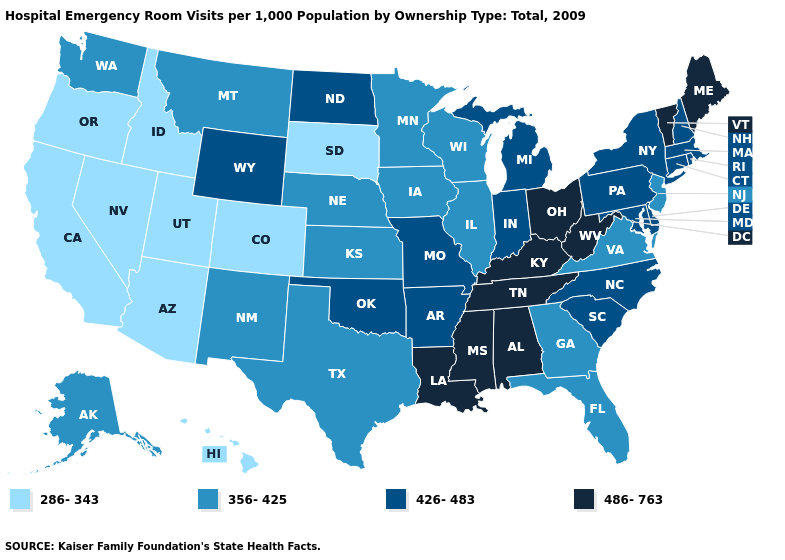Name the states that have a value in the range 426-483?
Short answer required. Arkansas, Connecticut, Delaware, Indiana, Maryland, Massachusetts, Michigan, Missouri, New Hampshire, New York, North Carolina, North Dakota, Oklahoma, Pennsylvania, Rhode Island, South Carolina, Wyoming. What is the value of Montana?
Write a very short answer. 356-425. Does California have a higher value than Michigan?
Answer briefly. No. Does the map have missing data?
Short answer required. No. What is the value of North Carolina?
Be succinct. 426-483. Name the states that have a value in the range 286-343?
Short answer required. Arizona, California, Colorado, Hawaii, Idaho, Nevada, Oregon, South Dakota, Utah. What is the value of Maine?
Quick response, please. 486-763. Does Alabama have the same value as Mississippi?
Give a very brief answer. Yes. What is the value of Arizona?
Quick response, please. 286-343. Name the states that have a value in the range 286-343?
Be succinct. Arizona, California, Colorado, Hawaii, Idaho, Nevada, Oregon, South Dakota, Utah. Which states hav the highest value in the South?
Concise answer only. Alabama, Kentucky, Louisiana, Mississippi, Tennessee, West Virginia. Does Oregon have the lowest value in the West?
Short answer required. Yes. Name the states that have a value in the range 356-425?
Keep it brief. Alaska, Florida, Georgia, Illinois, Iowa, Kansas, Minnesota, Montana, Nebraska, New Jersey, New Mexico, Texas, Virginia, Washington, Wisconsin. Which states have the highest value in the USA?
Give a very brief answer. Alabama, Kentucky, Louisiana, Maine, Mississippi, Ohio, Tennessee, Vermont, West Virginia. 